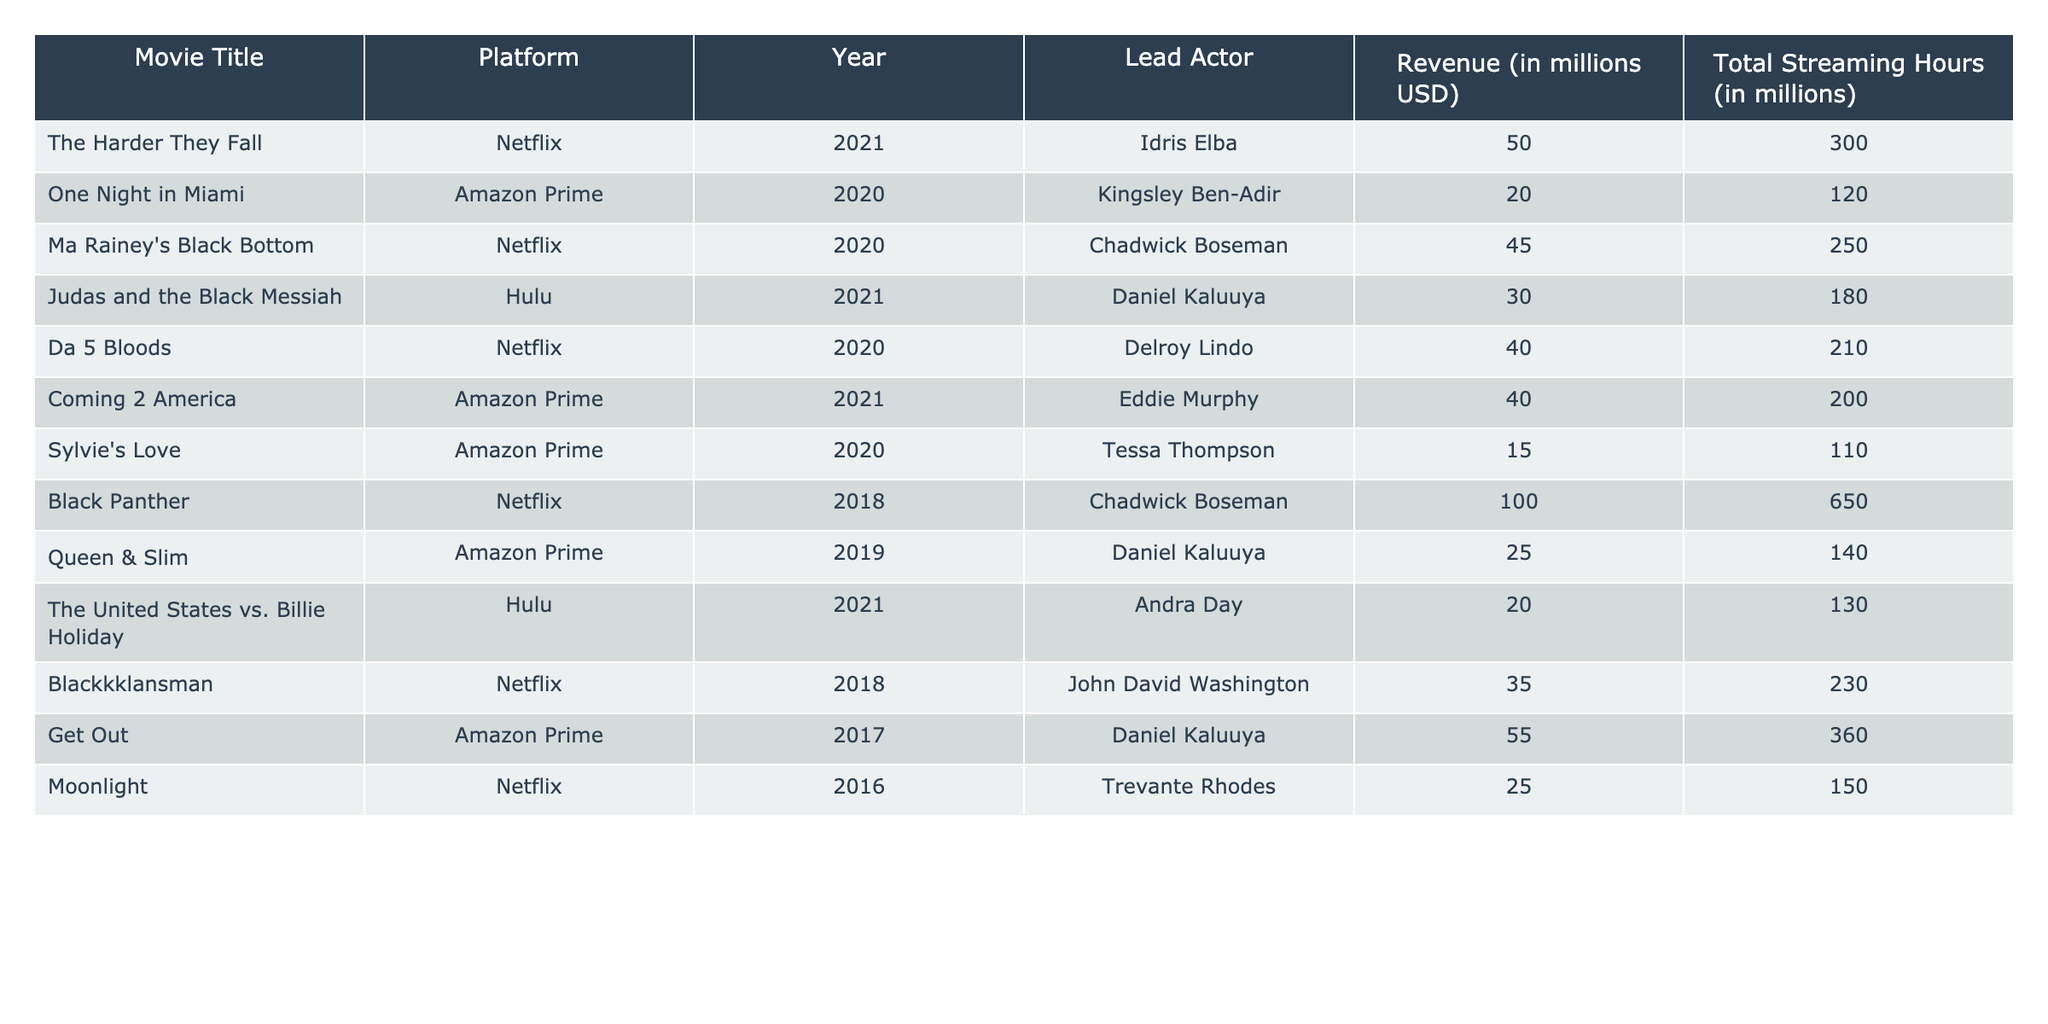What is the revenue of "Black Panther"? In the table, the revenue for "Black Panther" is listed under the Revenue (in millions USD) column, which shows 100 million USD.
Answer: 100 million USD Which movie features Daniel Kaluuya and what platform is it on? From the table, we can see that Daniel Kaluuya stars in "Judas and the Black Messiah," which is on Hulu.
Answer: "Judas and the Black Messiah", Hulu What is the total streaming revenue for movies on Netflix? To find the total streaming revenue for Netflix, we add the revenues of all movies on that platform: 50 + 45 + 40 + 100 + 35 + 25 = 295 million USD.
Answer: 295 million USD Does "Coming 2 America" have more total streaming hours than "One Night in Miami"? "Coming 2 America" has 200 million streaming hours, while "One Night in Miami" has 120 million. Since 200 is greater than 120, the statement is true.
Answer: Yes Which movie had the highest revenue and what was that value? By reviewing the revenue numbers, "Black Panther" has the highest revenue with 100 million USD.
Answer: "Black Panther", 100 million USD What is the average revenue of the movies featuring Chadwick Boseman? Chadwick Boseman stars in two movies: "Ma Rainey's Black Bottom" with 45 million and "Black Panther" with 100 million. Summing these gives 145 million, and dividing by 2 yields an average of 72.5 million USD.
Answer: 72.5 million USD Is it true that "Da 5 Bloods" generated more total streaming hours than "Get Out"? "Da 5 Bloods" has 210 million streaming hours, while "Get Out" has 360 million. Since 210 is less than 360, the statement is false.
Answer: No Which movies feature Eddie Murphy and how much revenue did they generate? The only movie featuring Eddie Murphy in this table is "Coming 2 America," which generated 40 million USD in revenue.
Answer: "Coming 2 America", 40 million USD How many movies have a revenue greater than 30 million USD on Amazon Prime? The movies on Amazon Prime with revenues greater than 30 million USD are "Get Out" (55 million) and "Coming 2 America" (40 million). That adds up to two movies.
Answer: 2 